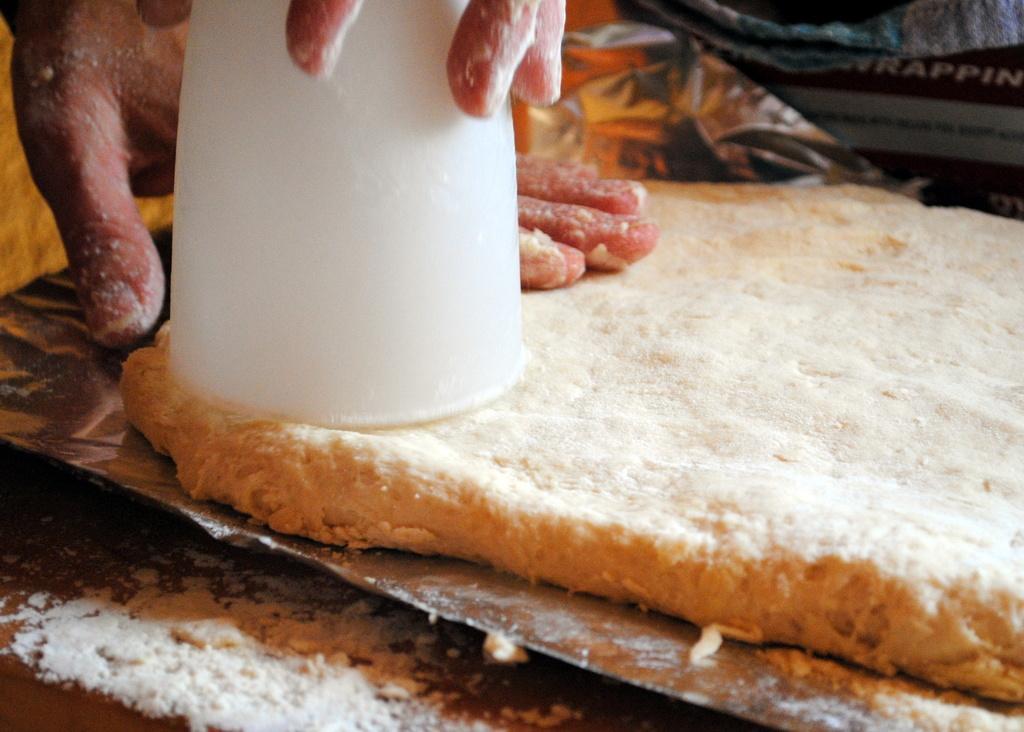How would you summarize this image in a sentence or two? In this image I can see some white colored flour, a tray and on the tray I can see the flour dough. I can see persons hands holding a white colored object on the dough. In the background I can see few other objects. 